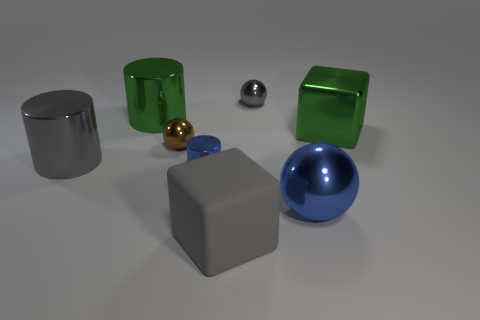Subtract all large spheres. How many spheres are left? 2 Subtract all blue spheres. How many spheres are left? 2 Subtract all spheres. How many objects are left? 5 Add 2 green shiny blocks. How many objects exist? 10 Subtract 2 blocks. How many blocks are left? 0 Subtract all cyan cylinders. Subtract all gray spheres. How many cylinders are left? 3 Subtract all yellow cylinders. How many gray blocks are left? 1 Subtract all large cylinders. Subtract all large cylinders. How many objects are left? 4 Add 8 brown metal spheres. How many brown metal spheres are left? 9 Add 6 small cyan rubber cylinders. How many small cyan rubber cylinders exist? 6 